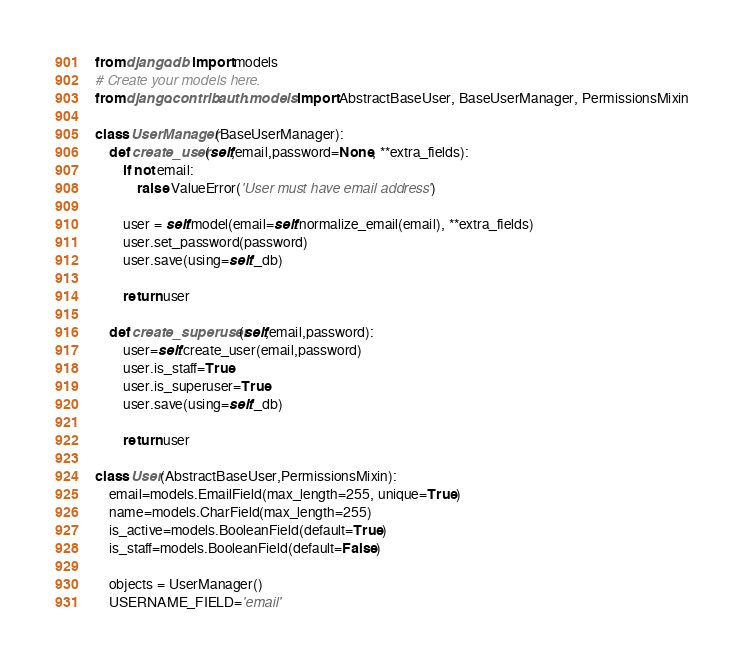<code> <loc_0><loc_0><loc_500><loc_500><_Python_>from django.db import models
# Create your models here.
from django.contrib.auth.models import AbstractBaseUser, BaseUserManager, PermissionsMixin

class UserManager(BaseUserManager):
    def create_user(self,email,password=None, **extra_fields):
        if not email:
            raise ValueError('User must have email address')

        user = self.model(email=self.normalize_email(email), **extra_fields)
        user.set_password(password)
        user.save(using=self._db)

        return user

    def create_superuser(self,email,password):
        user=self.create_user(email,password)
        user.is_staff=True
        user.is_superuser=True
        user.save(using=self._db)

        return user

class User(AbstractBaseUser,PermissionsMixin):
    email=models.EmailField(max_length=255, unique=True)
    name=models.CharField(max_length=255)
    is_active=models.BooleanField(default=True)
    is_staff=models.BooleanField(default=False)

    objects = UserManager()
    USERNAME_FIELD='email'
</code> 